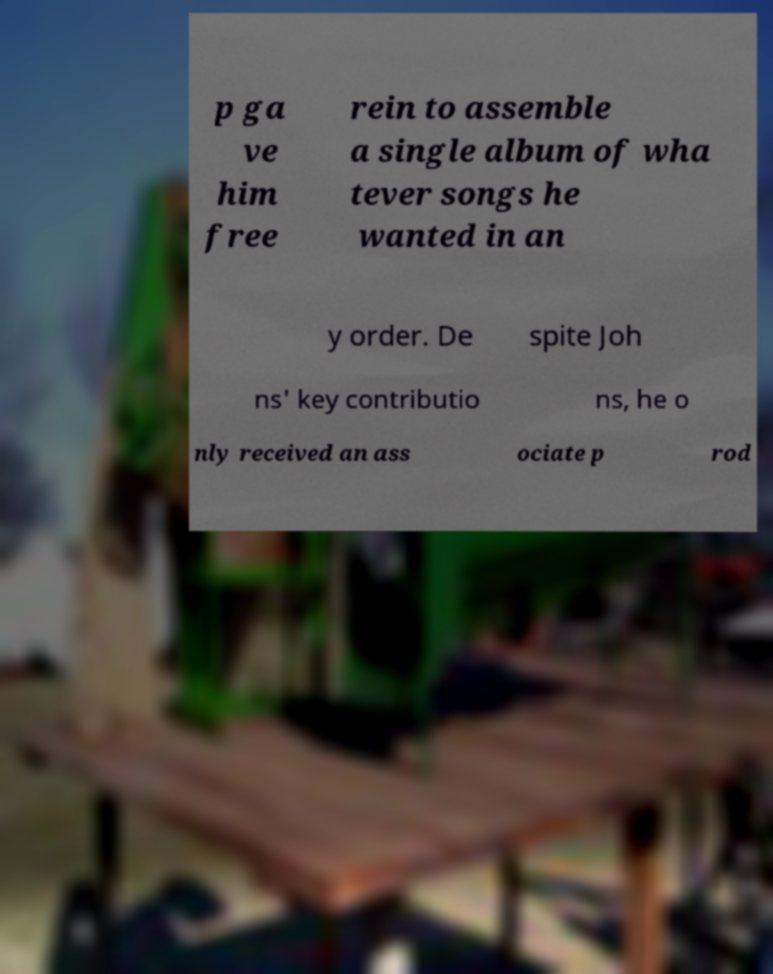Can you read and provide the text displayed in the image?This photo seems to have some interesting text. Can you extract and type it out for me? p ga ve him free rein to assemble a single album of wha tever songs he wanted in an y order. De spite Joh ns' key contributio ns, he o nly received an ass ociate p rod 